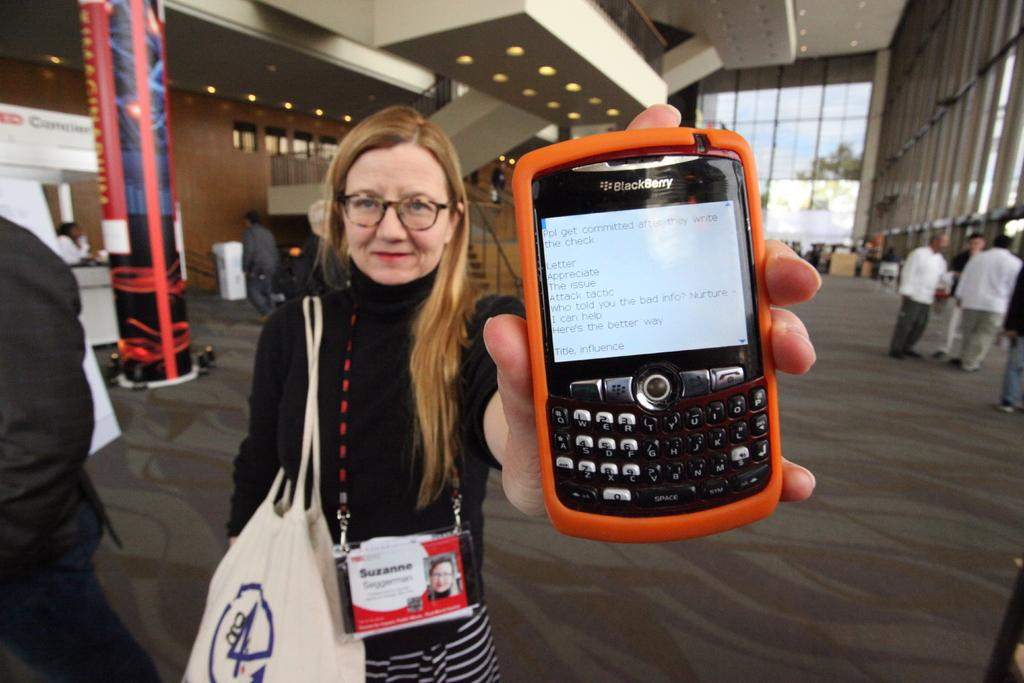Provide a one-sentence caption for the provided image. A woman holding a Blackberry with an orange case on it. 